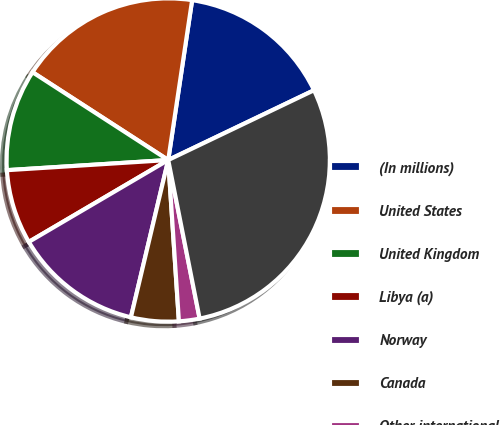Convert chart to OTSL. <chart><loc_0><loc_0><loc_500><loc_500><pie_chart><fcel>(In millions)<fcel>United States<fcel>United Kingdom<fcel>Libya (a)<fcel>Norway<fcel>Canada<fcel>Other international<fcel>Total revenues<nl><fcel>15.53%<fcel>18.22%<fcel>10.14%<fcel>7.45%<fcel>12.84%<fcel>4.76%<fcel>2.06%<fcel>28.99%<nl></chart> 